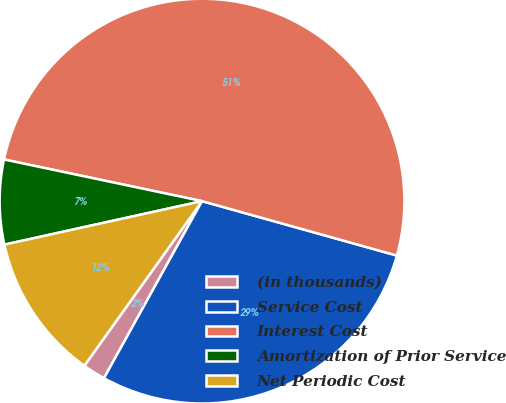Convert chart to OTSL. <chart><loc_0><loc_0><loc_500><loc_500><pie_chart><fcel>(in thousands)<fcel>Service Cost<fcel>Interest Cost<fcel>Amortization of Prior Service<fcel>Net Periodic Cost<nl><fcel>1.83%<fcel>28.71%<fcel>51.03%<fcel>6.75%<fcel>11.67%<nl></chart> 